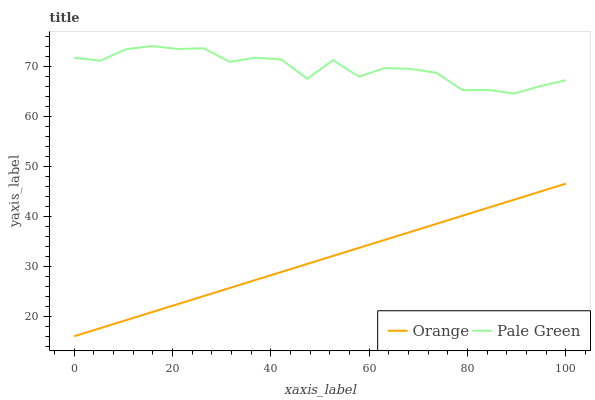Does Orange have the minimum area under the curve?
Answer yes or no. Yes. Does Pale Green have the maximum area under the curve?
Answer yes or no. Yes. Does Pale Green have the minimum area under the curve?
Answer yes or no. No. Is Orange the smoothest?
Answer yes or no. Yes. Is Pale Green the roughest?
Answer yes or no. Yes. Is Pale Green the smoothest?
Answer yes or no. No. Does Pale Green have the lowest value?
Answer yes or no. No. Does Pale Green have the highest value?
Answer yes or no. Yes. Is Orange less than Pale Green?
Answer yes or no. Yes. Is Pale Green greater than Orange?
Answer yes or no. Yes. Does Orange intersect Pale Green?
Answer yes or no. No. 